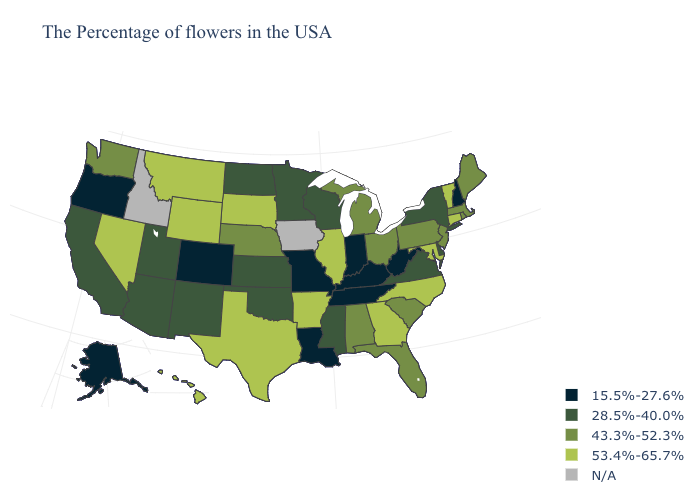Name the states that have a value in the range 15.5%-27.6%?
Short answer required. New Hampshire, West Virginia, Kentucky, Indiana, Tennessee, Louisiana, Missouri, Colorado, Oregon, Alaska. What is the value of Nevada?
Quick response, please. 53.4%-65.7%. Name the states that have a value in the range 43.3%-52.3%?
Concise answer only. Maine, Massachusetts, Rhode Island, New Jersey, Pennsylvania, South Carolina, Ohio, Florida, Michigan, Alabama, Nebraska, Washington. What is the highest value in the South ?
Quick response, please. 53.4%-65.7%. What is the value of Massachusetts?
Answer briefly. 43.3%-52.3%. Does Massachusetts have the highest value in the Northeast?
Give a very brief answer. No. Name the states that have a value in the range 15.5%-27.6%?
Be succinct. New Hampshire, West Virginia, Kentucky, Indiana, Tennessee, Louisiana, Missouri, Colorado, Oregon, Alaska. Does Oregon have the lowest value in the USA?
Write a very short answer. Yes. How many symbols are there in the legend?
Keep it brief. 5. What is the lowest value in the USA?
Keep it brief. 15.5%-27.6%. What is the lowest value in states that border North Dakota?
Write a very short answer. 28.5%-40.0%. Name the states that have a value in the range 15.5%-27.6%?
Short answer required. New Hampshire, West Virginia, Kentucky, Indiana, Tennessee, Louisiana, Missouri, Colorado, Oregon, Alaska. What is the highest value in the USA?
Short answer required. 53.4%-65.7%. Does the map have missing data?
Keep it brief. Yes. 